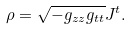Convert formula to latex. <formula><loc_0><loc_0><loc_500><loc_500>\rho = \sqrt { - g _ { z z } g _ { t t } } J ^ { t } .</formula> 